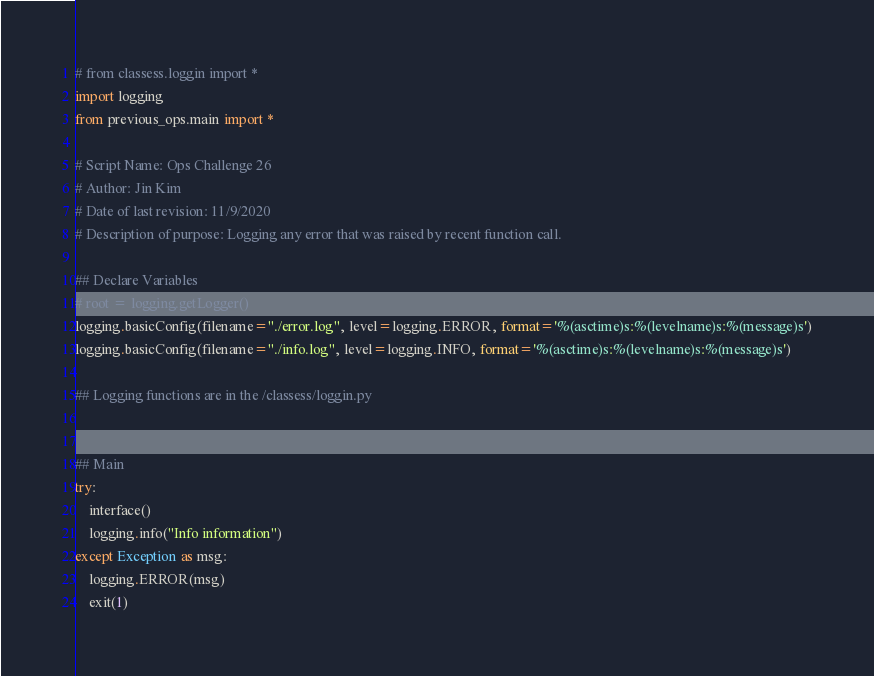Convert code to text. <code><loc_0><loc_0><loc_500><loc_500><_Python_># from classess.loggin import *
import logging
from previous_ops.main import *

# Script Name: Ops Challenge 26
# Author: Jin Kim
# Date of last revision: 11/9/2020
# Description of purpose: Logging any error that was raised by recent function call.

## Declare Variables
# root = logging.getLogger()
logging.basicConfig(filename="./error.log", level=logging.ERROR, format='%(asctime)s:%(levelname)s:%(message)s')
logging.basicConfig(filename="./info.log", level=logging.INFO, format='%(asctime)s:%(levelname)s:%(message)s')

## Logging functions are in the /classess/loggin.py


## Main
try:
    interface()
    logging.info("Info information")
except Exception as msg:
    logging.ERROR(msg)
    exit(1)</code> 